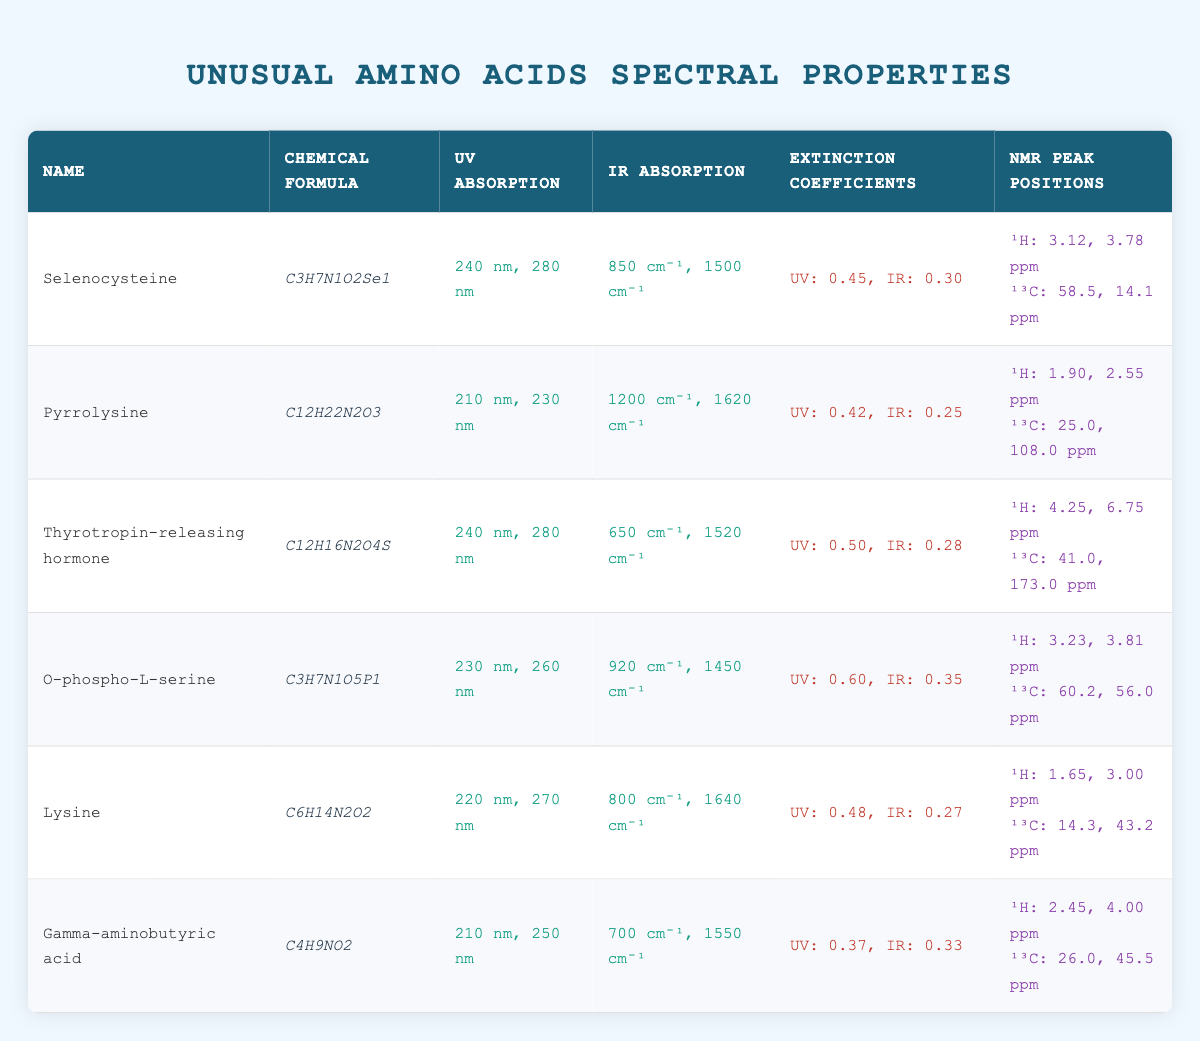What are the UV absorption wavelengths for Thyrotropin-releasing hormone? From the table, I find that Thyrotropin-releasing hormone has UV absorption wavelengths of 240 nm and 280 nm listed under the respective column.
Answer: 240 nm, 280 nm Which unusual amino acid has the highest extinction coefficient in the UV range? By comparing the UV extinction coefficients from the table, I see Selenocysteine has 0.45, Pyrrolysine has 0.42, Thyrotropin-releasing hormone has 0.50, O-phospho-L-serine has 0.60, Lysine has 0.48, and Gamma-aminobutyric acid has 0.37. Among these, O-phospho-L-serine has the highest value of 0.60.
Answer: O-phospho-L-serine Is it true that Lysine has absorption wavelengths in both the UV and IR ranges? The table indicates that Lysine has absorption wavelengths of 220 nm and 270 nm for UV and 800 cm⁻¹ and 1640 cm⁻¹ for IR, confirming that it has wavelengths in both ranges.
Answer: Yes What is the difference between the lowest and highest 1H NMR peak positions listed? The lowest 1H NMR peak position across the amino acids is 1.65 (Lysine), while the highest is 6.75 (Thyrotropin-releasing hormone). The difference is calculated as 6.75 - 1.65 = 5.10.
Answer: 5.10 Which amino acid has the lowest IR extinction coefficient? Reviewing the IR extinction coefficients, I find that Pyrrolysine has 0.25, Selenocysteine has 0.30, Thyrotropin-releasing hormone has 0.28, O-phospho-L-serine has 0.35, Lysine has 0.27, and Gamma-aminobutyric acid has 0.33. Therefore, Pyrrolysine has the lowest IR extinction coefficient of 0.25.
Answer: Pyrrolysine What two unusual amino acids share the same UV absorption wavelengths of 240 and 280 nm? From the table, both Selenocysteine and Thyrotropin-releasing hormone have the same UV absorption wavelengths of 240 nm and 280 nm listed under their respective rows.
Answer: Selenocysteine, Thyrotropin-releasing hormone 